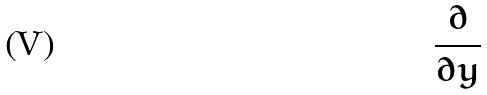<formula> <loc_0><loc_0><loc_500><loc_500>\frac { \partial } { \partial y }</formula> 